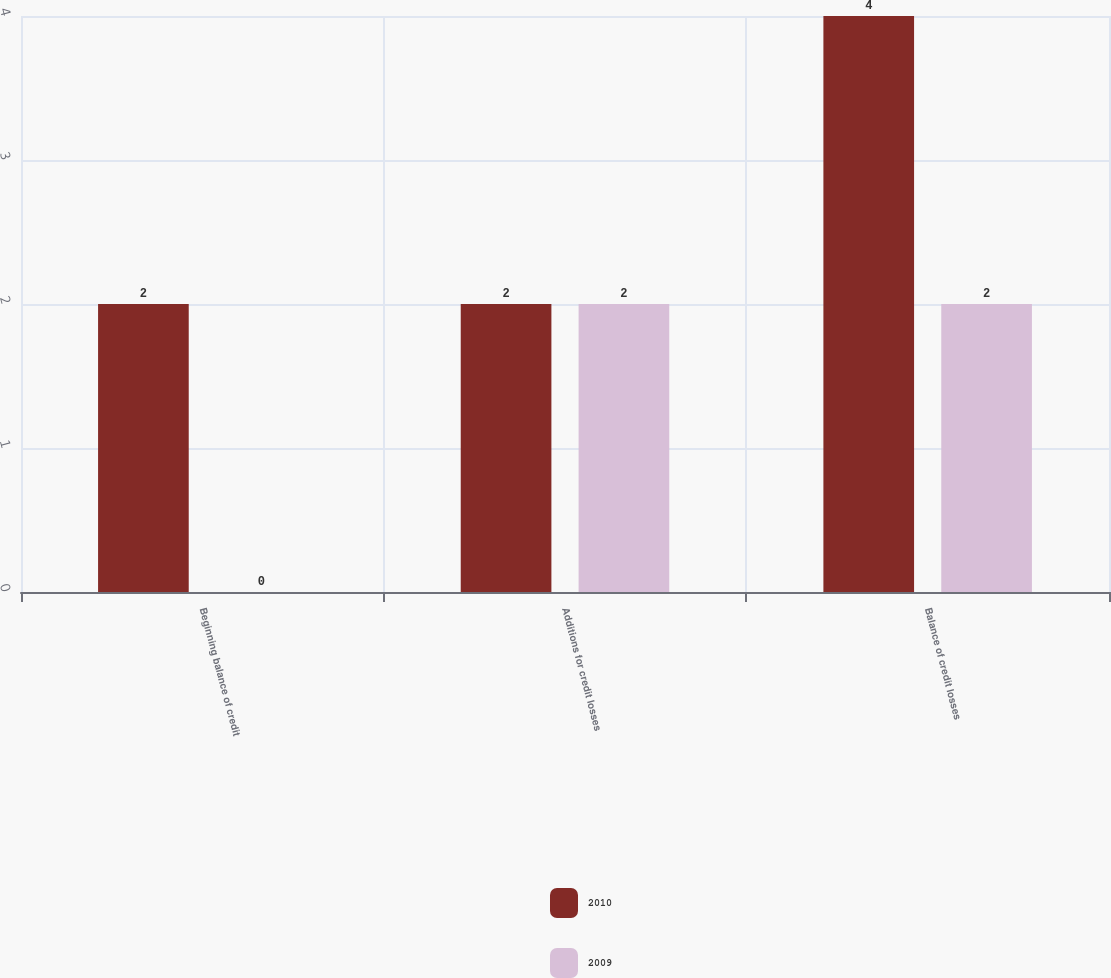Convert chart to OTSL. <chart><loc_0><loc_0><loc_500><loc_500><stacked_bar_chart><ecel><fcel>Beginning balance of credit<fcel>Additions for credit losses<fcel>Balance of credit losses<nl><fcel>2010<fcel>2<fcel>2<fcel>4<nl><fcel>2009<fcel>0<fcel>2<fcel>2<nl></chart> 